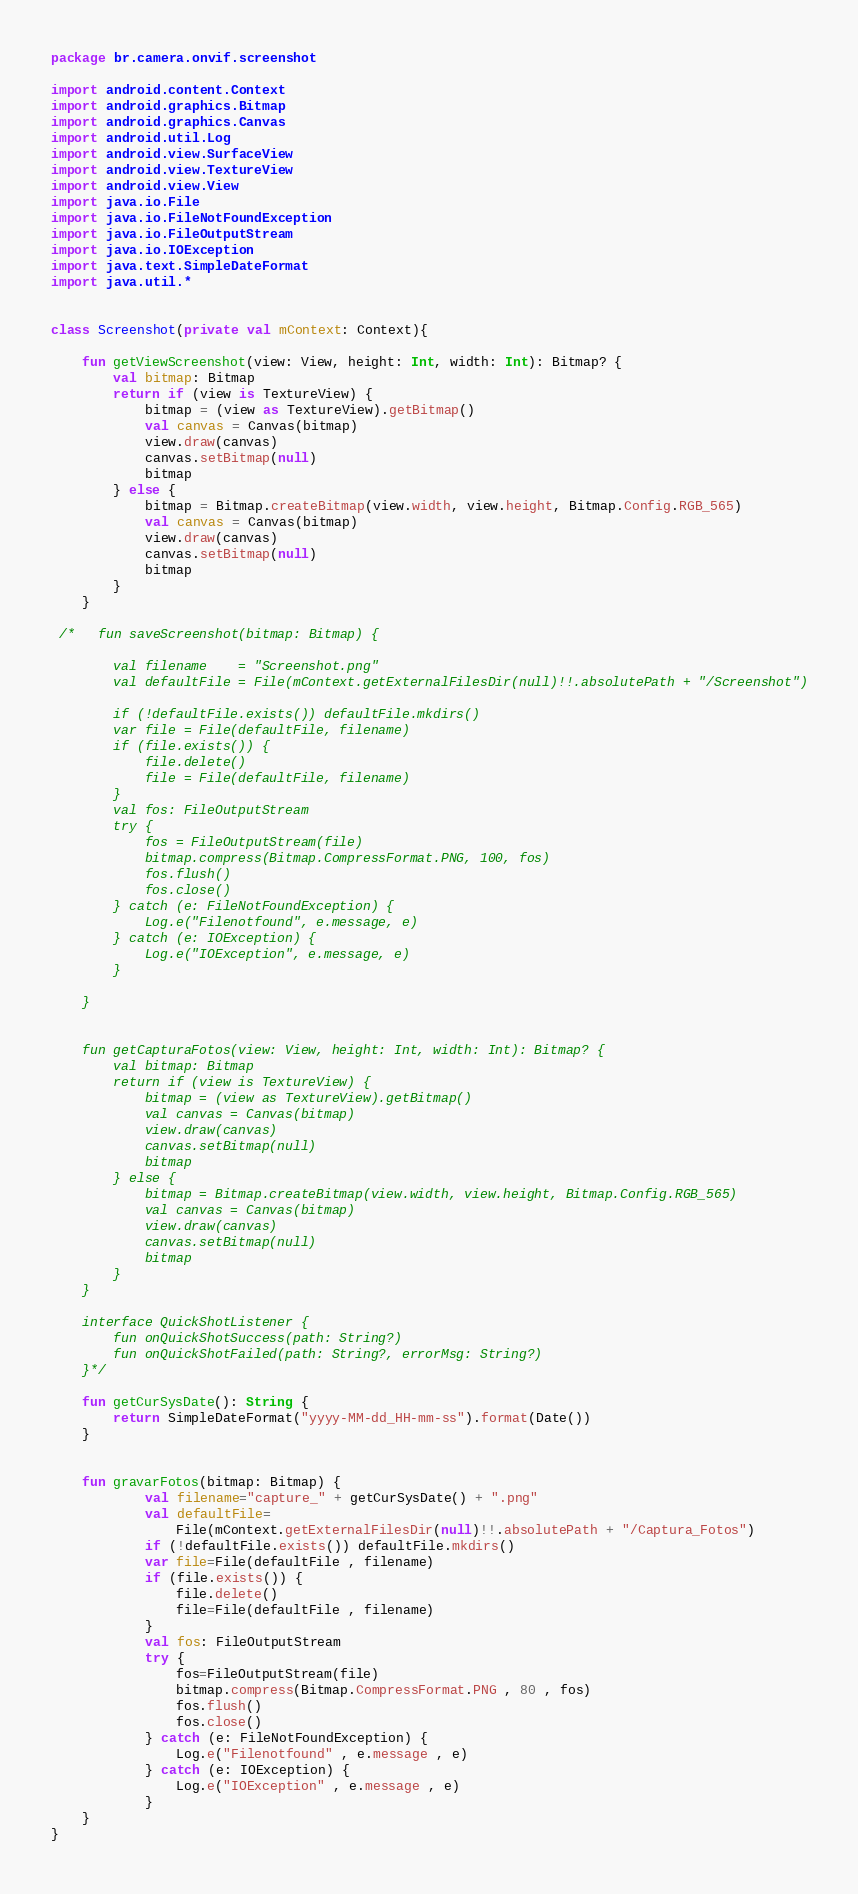Convert code to text. <code><loc_0><loc_0><loc_500><loc_500><_Kotlin_>package br.camera.onvif.screenshot

import android.content.Context
import android.graphics.Bitmap
import android.graphics.Canvas
import android.util.Log
import android.view.SurfaceView
import android.view.TextureView
import android.view.View
import java.io.File
import java.io.FileNotFoundException
import java.io.FileOutputStream
import java.io.IOException
import java.text.SimpleDateFormat
import java.util.*


class Screenshot(private val mContext: Context){

    fun getViewScreenshot(view: View, height: Int, width: Int): Bitmap? {
        val bitmap: Bitmap
        return if (view is TextureView) {
            bitmap = (view as TextureView).getBitmap()
            val canvas = Canvas(bitmap)
            view.draw(canvas)
            canvas.setBitmap(null)
            bitmap
        } else {
            bitmap = Bitmap.createBitmap(view.width, view.height, Bitmap.Config.RGB_565)
            val canvas = Canvas(bitmap)
            view.draw(canvas)
            canvas.setBitmap(null)
            bitmap
        }
    }

 /*   fun saveScreenshot(bitmap: Bitmap) {

        val filename    = "Screenshot.png"
        val defaultFile = File(mContext.getExternalFilesDir(null)!!.absolutePath + "/Screenshot")

        if (!defaultFile.exists()) defaultFile.mkdirs()
        var file = File(defaultFile, filename)
        if (file.exists()) {
            file.delete()
            file = File(defaultFile, filename)
        }
        val fos: FileOutputStream
        try {
            fos = FileOutputStream(file)
            bitmap.compress(Bitmap.CompressFormat.PNG, 100, fos)
            fos.flush()
            fos.close()
        } catch (e: FileNotFoundException) {
            Log.e("Filenotfound", e.message, e)
        } catch (e: IOException) {
            Log.e("IOException", e.message, e)
        }

    }


    fun getCapturaFotos(view: View, height: Int, width: Int): Bitmap? {
        val bitmap: Bitmap
        return if (view is TextureView) {
            bitmap = (view as TextureView).getBitmap()
            val canvas = Canvas(bitmap)
            view.draw(canvas)
            canvas.setBitmap(null)
            bitmap
        } else {
            bitmap = Bitmap.createBitmap(view.width, view.height, Bitmap.Config.RGB_565)
            val canvas = Canvas(bitmap)
            view.draw(canvas)
            canvas.setBitmap(null)
            bitmap
        }
    }

    interface QuickShotListener {
        fun onQuickShotSuccess(path: String?)
        fun onQuickShotFailed(path: String?, errorMsg: String?)
    }*/

    fun getCurSysDate(): String {
        return SimpleDateFormat("yyyy-MM-dd_HH-mm-ss").format(Date())
    }


    fun gravarFotos(bitmap: Bitmap) {
            val filename="capture_" + getCurSysDate() + ".png"
            val defaultFile=
                File(mContext.getExternalFilesDir(null)!!.absolutePath + "/Captura_Fotos")
            if (!defaultFile.exists()) defaultFile.mkdirs()
            var file=File(defaultFile , filename)
            if (file.exists()) {
                file.delete()
                file=File(defaultFile , filename)
            }
            val fos: FileOutputStream
            try {
                fos=FileOutputStream(file)
                bitmap.compress(Bitmap.CompressFormat.PNG , 80 , fos)
                fos.flush()
                fos.close()
            } catch (e: FileNotFoundException) {
                Log.e("Filenotfound" , e.message , e)
            } catch (e: IOException) {
                Log.e("IOException" , e.message , e)
            }
    }
}</code> 